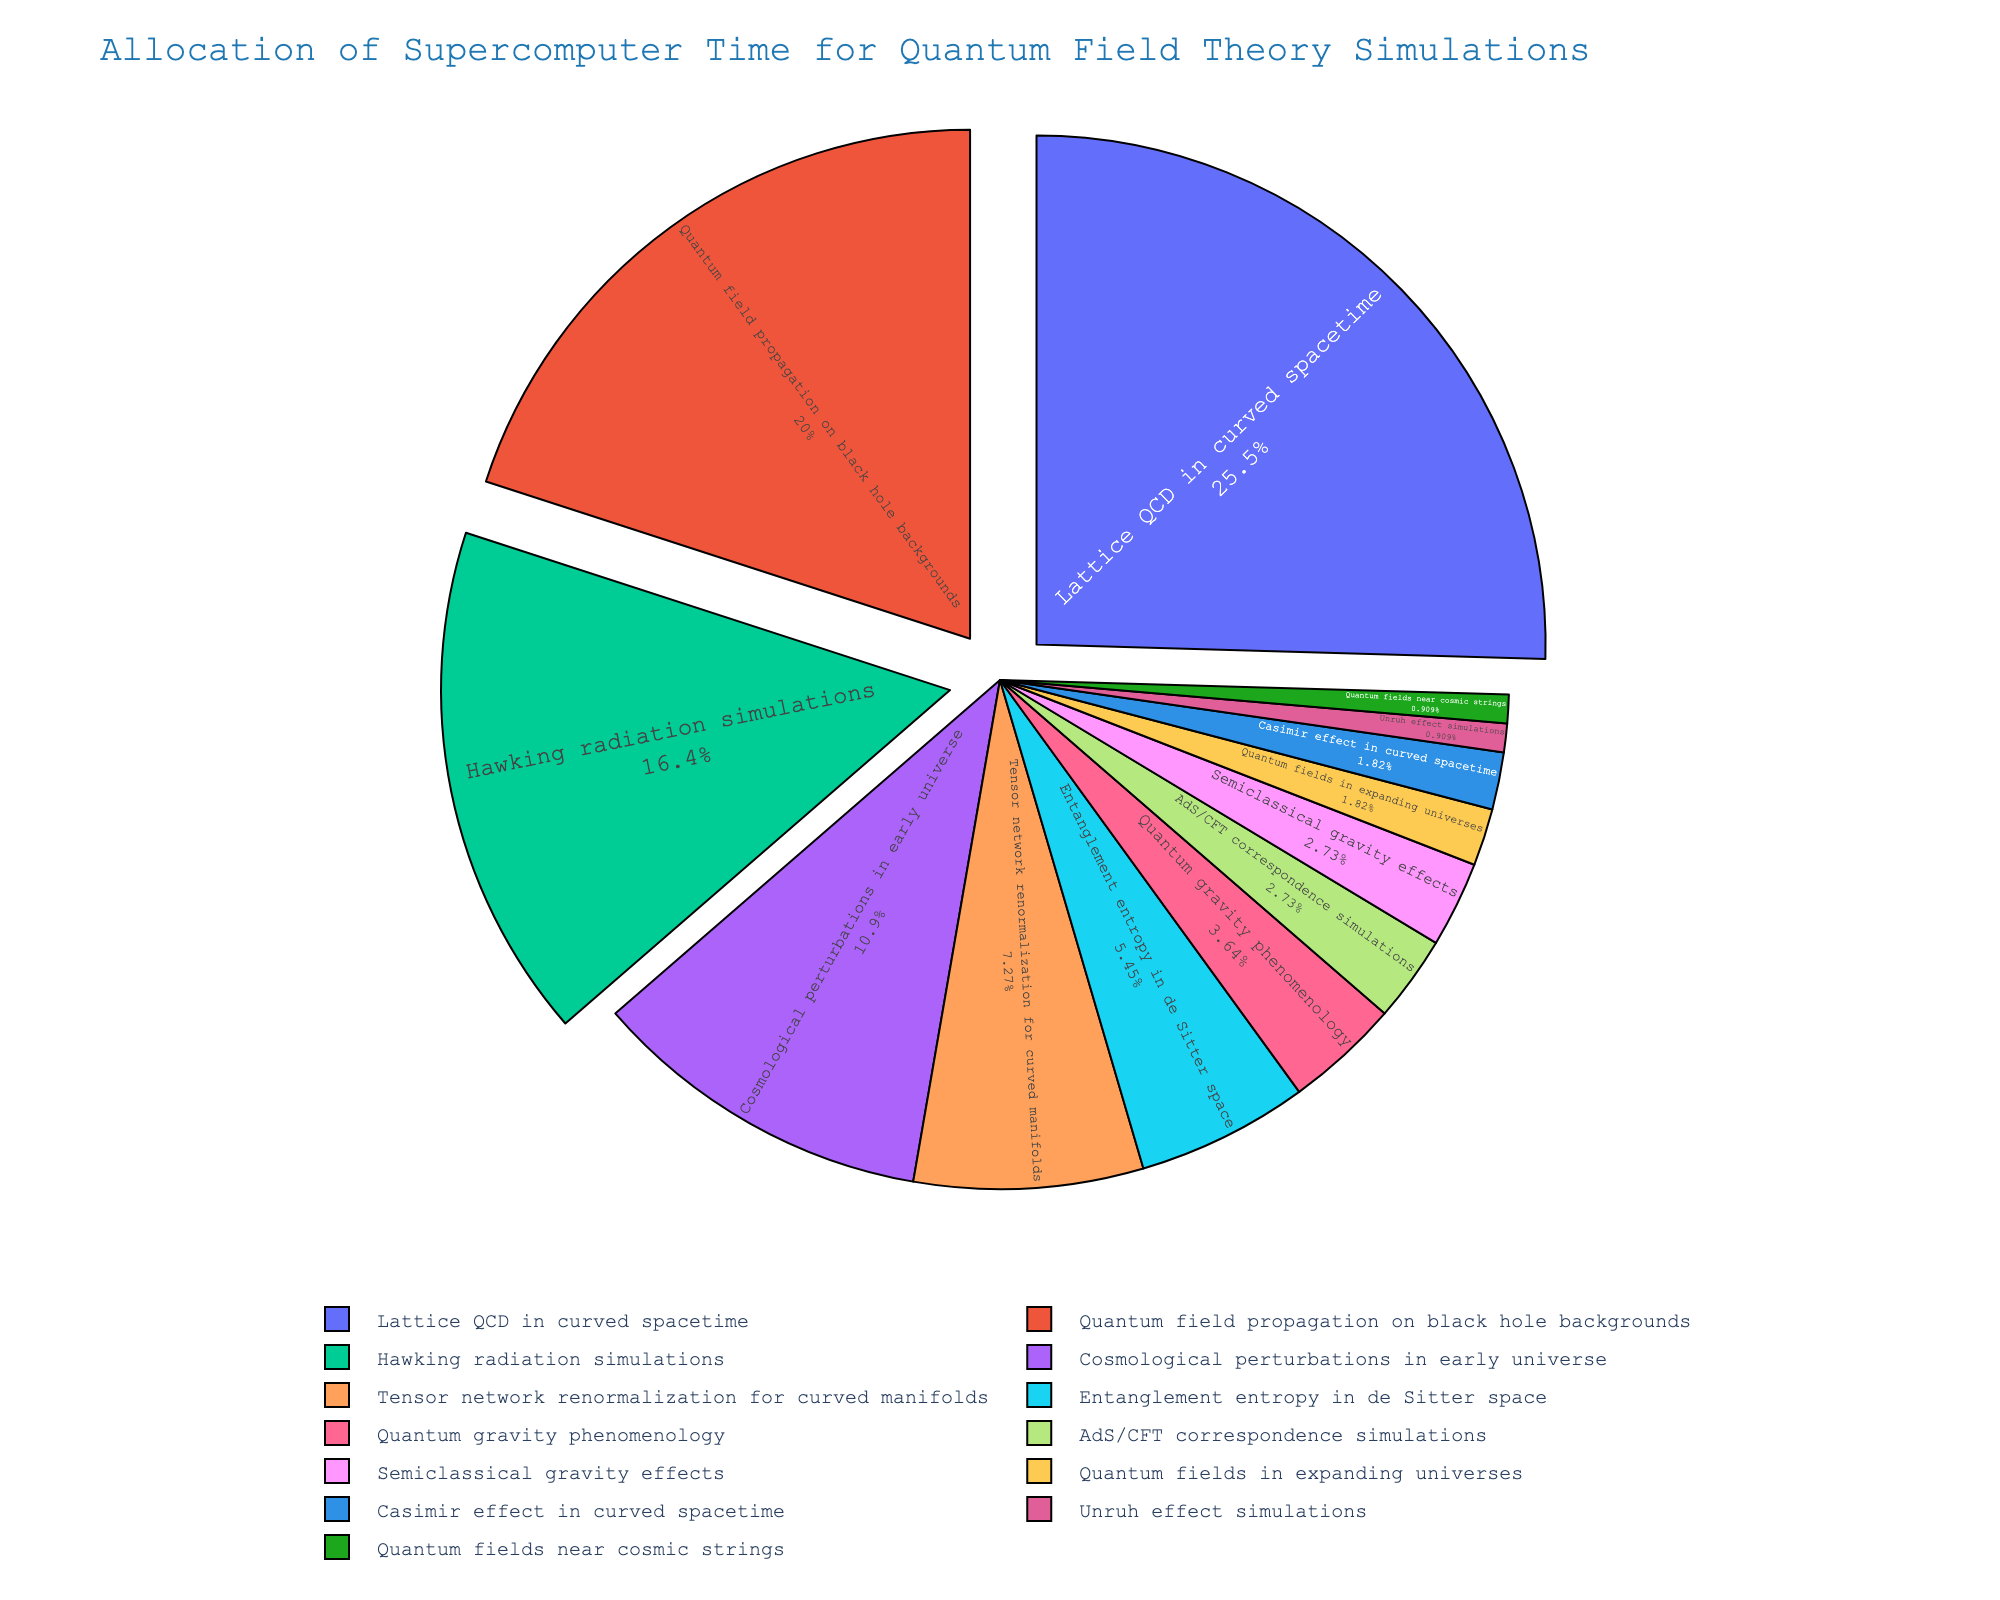Which category has the largest allocation of supercomputer time? The largest percentage slice on the pie chart corresponds to "Lattice QCD in curved spacetime" with 28%.
Answer: "Lattice QCD in curved spacetime" Which category has the smallest allocation of supercomputer time? The smallest percentage slice on the pie chart is for "Quantum fields near cosmic strings" and "Unruh effect simulations", each with 1%.
Answer: "Quantum fields near cosmic strings" and "Unruh effect simulations" How much more supercomputer time is allocated to "Lattice QCD in curved spacetime" compared to "Tensor network renormalization for curved manifolds"? "Lattice QCD in curved spacetime" has 28%, and "Tensor network renormalization for curved manifolds" has 8%. The difference is 28% - 8% = 20%.
Answer: 20% What's the combined percentage of supercomputer time for "Hawking radiation simulations" and "Quantum field propagation on black hole backgrounds"? The percentages are 18% and 22%, respectively. So, 18% + 22% = 40%.
Answer: 40% Which two categories combined make up the highest allocation of supercomputer time? The categories "Lattice QCD in curved spacetime" (28%) and "Quantum field propagation on black hole backgrounds" (22%) together total 50%, which is the highest combined allocation.
Answer: "Lattice QCD in curved spacetime" and "Quantum field propagation on black hole backgrounds" Is the percentage of supercomputer time allocation for "Entanglement entropy in de Sitter space" more or less than a quarter of the time allocated to "Lattice QCD in curved spacetime"? A quarter of 28% (time for "Lattice QCD in curved spacetime") is 7%. "Entanglement entropy in de Sitter space" has 6%, which is less than 7%.
Answer: Less What is the average percentage allocation for the "Hawking radiation simulations", "Cosmological perturbations in early universe", and "Quantum fields near cosmic strings"? The percentages are 18%, 12%, and 1%, respectively. The sum is 18% + 12% + 1% = 31%. The average is 31% / 3 = 10.33%.
Answer: 10.33% How does the allocation for "AdS/CFT correspondence simulations" compare with "Semiclassical gravity effects"? Both "AdS/CFT correspondence simulations" and "Semiclassical gravity effects" each have an allocation of 3%. Hence, they are equal.
Answer: Equal What is the total percentage allocation for all categories less than 5%? The categories under 5% are "Quantum gravity phenomenology" (4%), "AdS/CFT correspondence simulations" (3%), "Semiclassical gravity effects" (3%), "Quantum fields in expanding universes" (2%), "Casimir effect in curved spacetime" (2%), "Unruh effect simulations" (1%), and "Quantum fields near cosmic strings" (1%). Summing these: 4% + 3% + 3% + 2% + 2% + 1% + 1% = 16%.
Answer: 16% How do the visual sizes of the segments for "Entanglement entropy in de Sitter space" and "Quantum gravity phenomenology" compare? On the pie chart, the segment for "Entanglement entropy in de Sitter space" (6%) appears slightly larger in size than the segment for "Quantum gravity phenomenology" (4%).
Answer: "Entanglement entropy in de Sitter space" is larger 